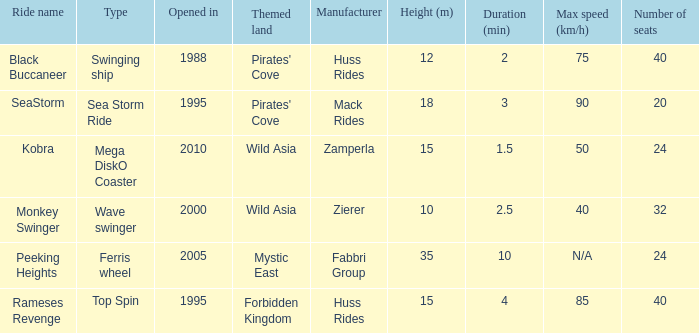What type of ride is Rameses Revenge? Top Spin. 